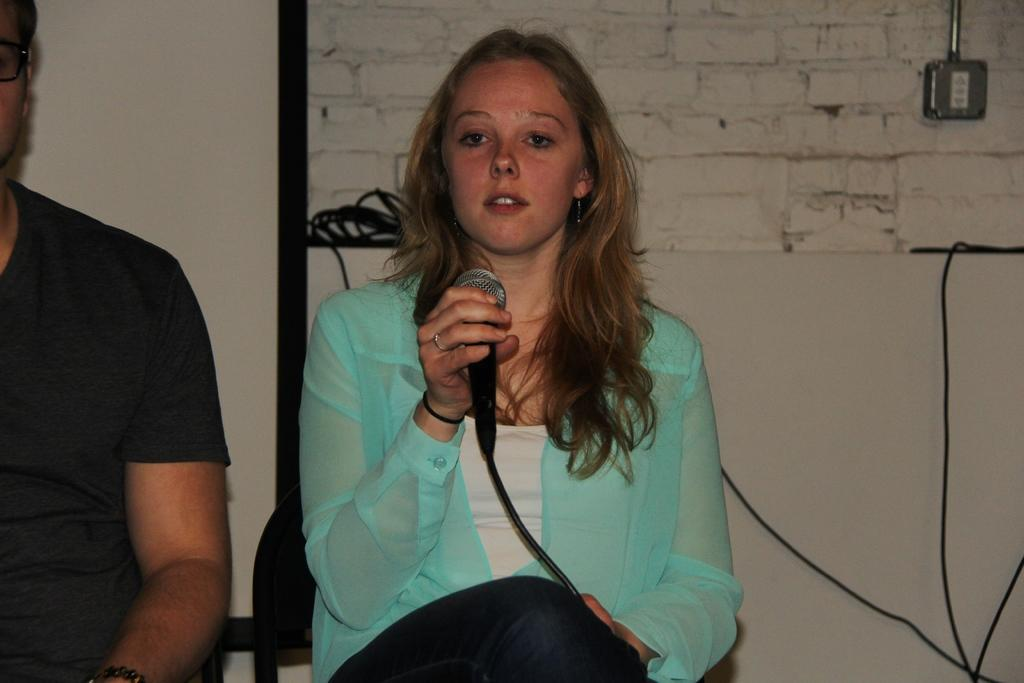Who is the main subject in the image? There is a woman in the image. What is the woman doing in the image? The woman is sitting on a chair and holding a microphone. What can be seen in the background of the image? There is a wall in the background of the image. How many mice can be seen running around the woman's feet in the image? There are no mice present in the image. 